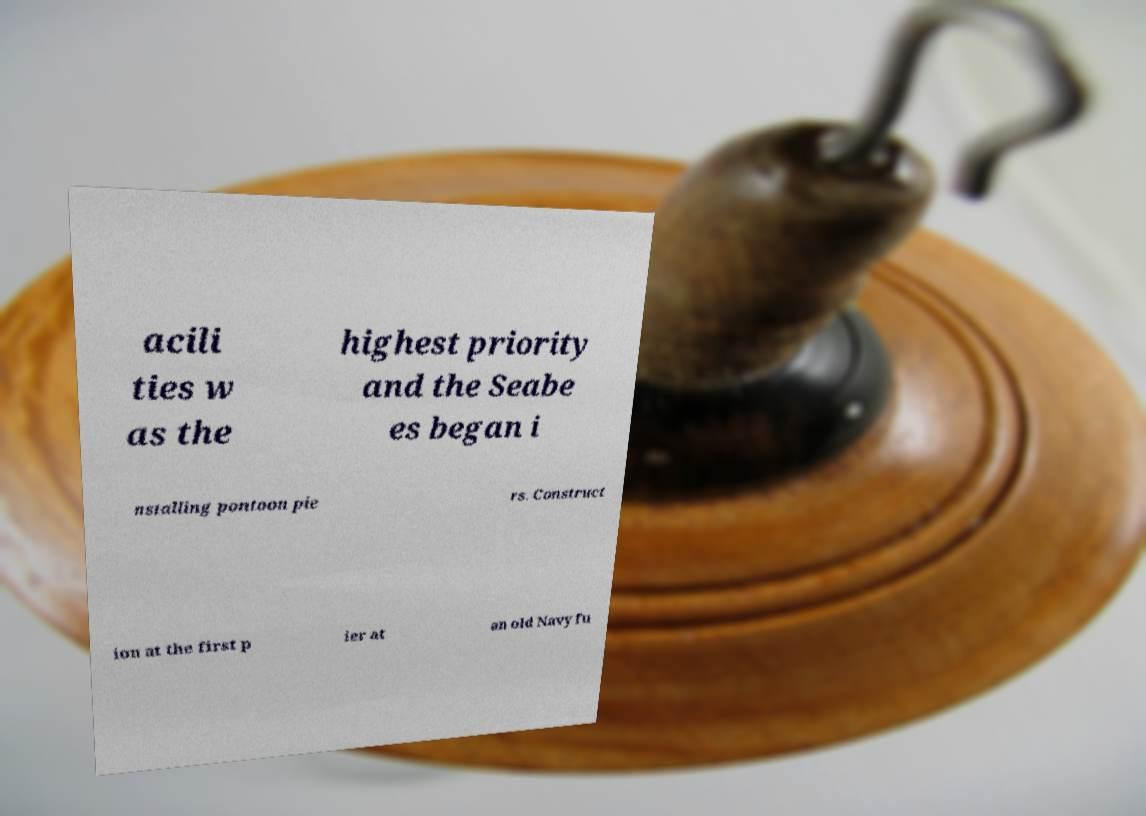There's text embedded in this image that I need extracted. Can you transcribe it verbatim? acili ties w as the highest priority and the Seabe es began i nstalling pontoon pie rs. Construct ion at the first p ier at an old Navy fu 